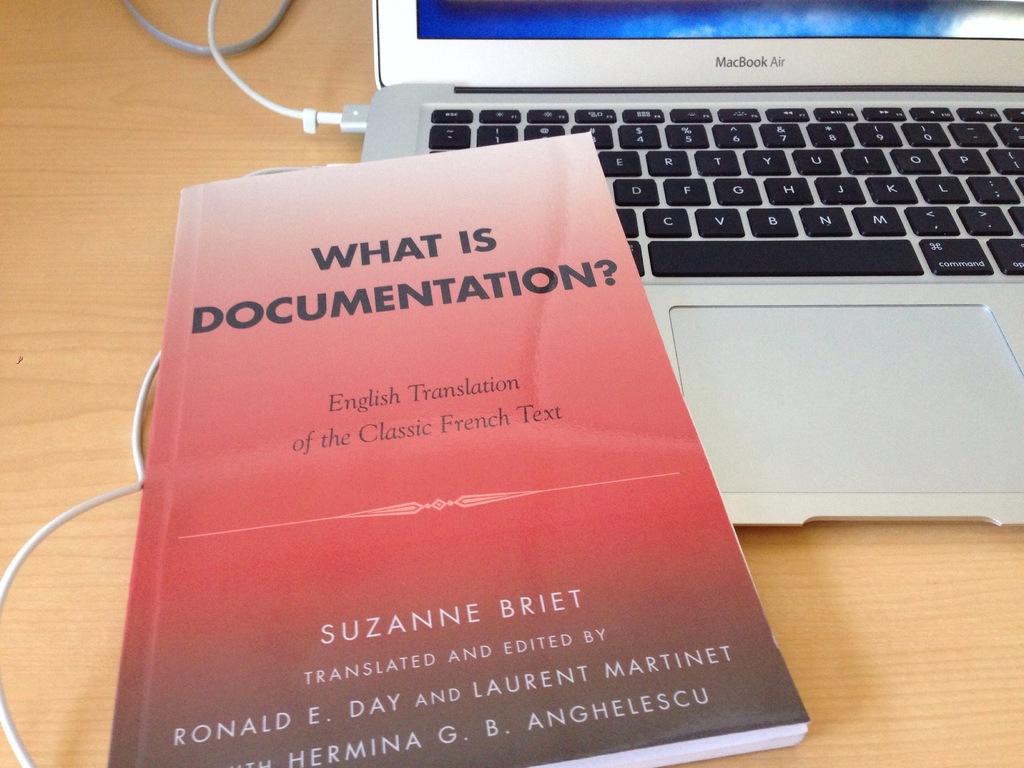What type of laptop is that?
Ensure brevity in your answer.  Macbook air. What is the name of the book?
Provide a short and direct response. What is documentation?. 